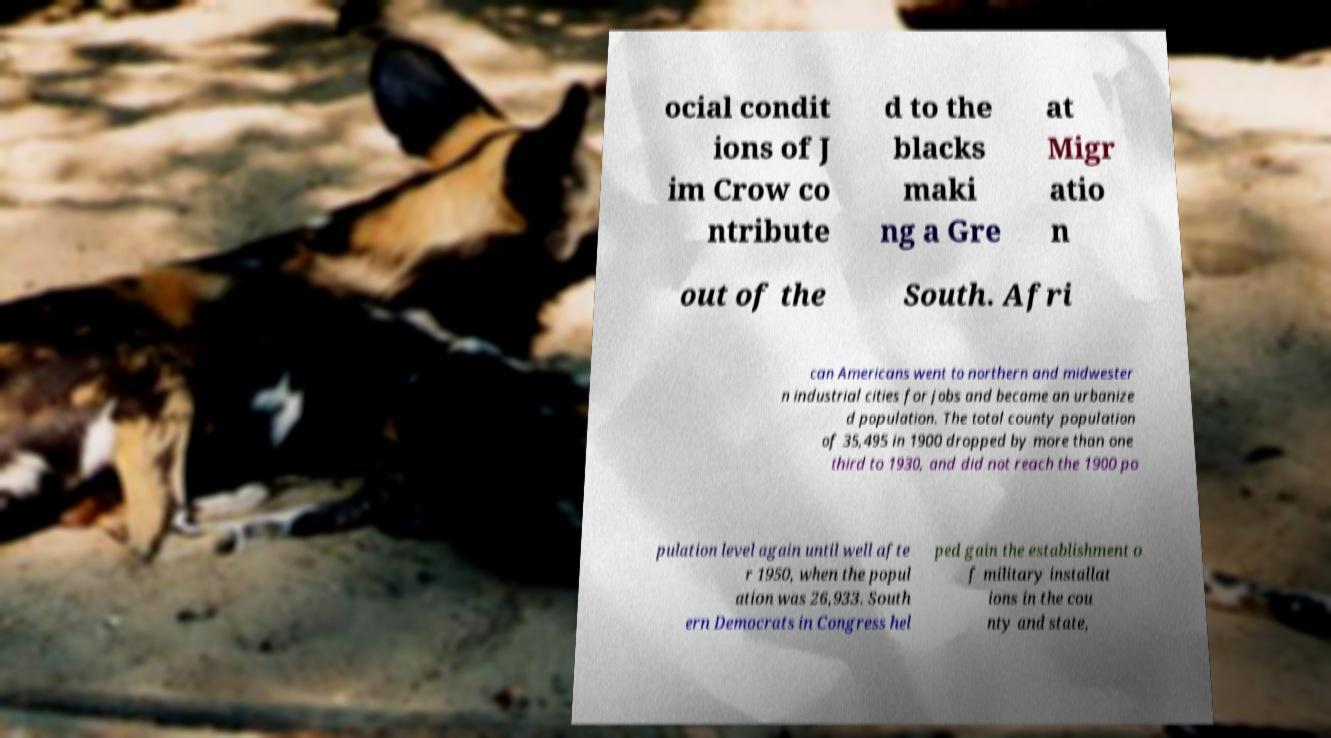I need the written content from this picture converted into text. Can you do that? ocial condit ions of J im Crow co ntribute d to the blacks maki ng a Gre at Migr atio n out of the South. Afri can Americans went to northern and midwester n industrial cities for jobs and became an urbanize d population. The total county population of 35,495 in 1900 dropped by more than one third to 1930, and did not reach the 1900 po pulation level again until well afte r 1950, when the popul ation was 26,933. South ern Democrats in Congress hel ped gain the establishment o f military installat ions in the cou nty and state, 